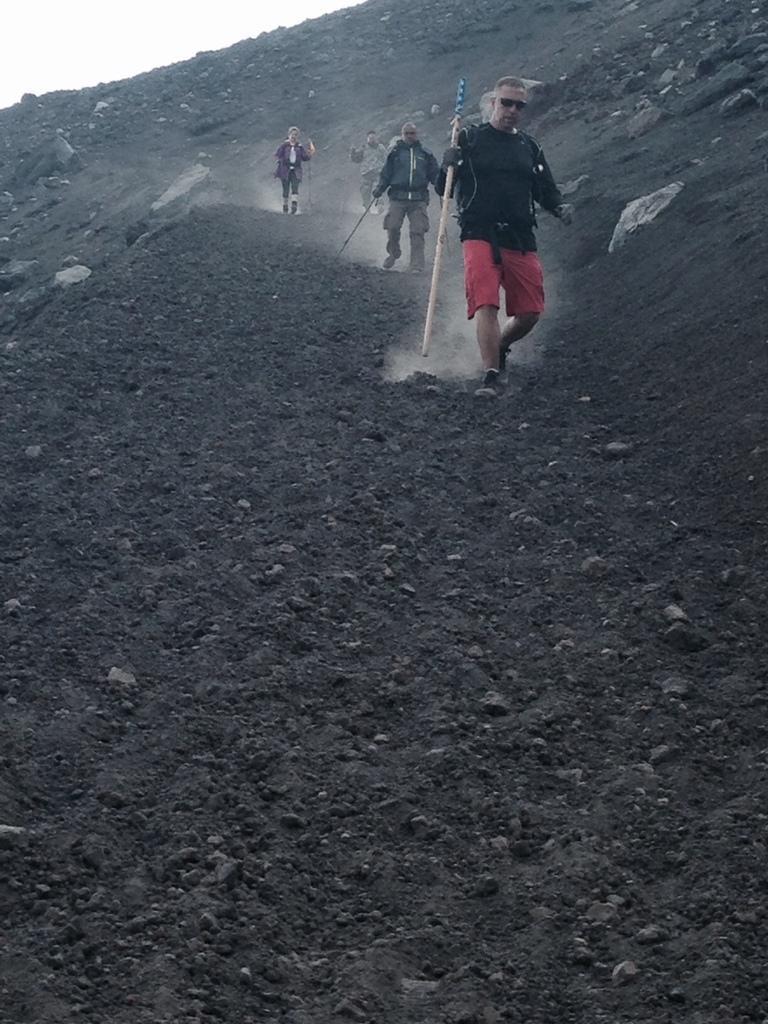Describe this image in one or two sentences. In this image there are four persons holding the sticks and walking on the hill, and in the background there is sky. 